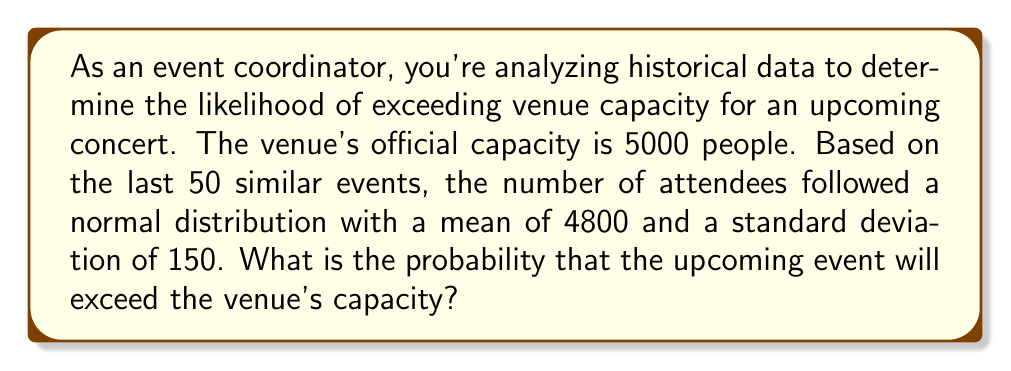Can you answer this question? To solve this problem, we need to use the properties of the normal distribution and calculate the z-score for the capacity limit. Then, we'll use a standard normal distribution table or calculator to find the probability.

Given:
- Venue capacity: 5000 people
- Mean attendance: $\mu = 4800$
- Standard deviation: $\sigma = 150$
- We want to find $P(X > 5000)$, where $X$ is the number of attendees

Steps:
1. Calculate the z-score for the capacity limit:
   $$z = \frac{X - \mu}{\sigma} = \frac{5000 - 4800}{150} = \frac{200}{150} = 1.33$$

2. The probability we're looking for is the area to the right of $z = 1.33$ on the standard normal distribution.

3. Using a standard normal distribution table or calculator, we find:
   $$P(Z > 1.33) = 1 - P(Z < 1.33) = 1 - 0.9082 = 0.0918$$

Therefore, the probability of exceeding the venue capacity is approximately 0.0918 or 9.18%.
Answer: The probability that the upcoming event will exceed the venue's capacity is approximately 0.0918 or 9.18%. 